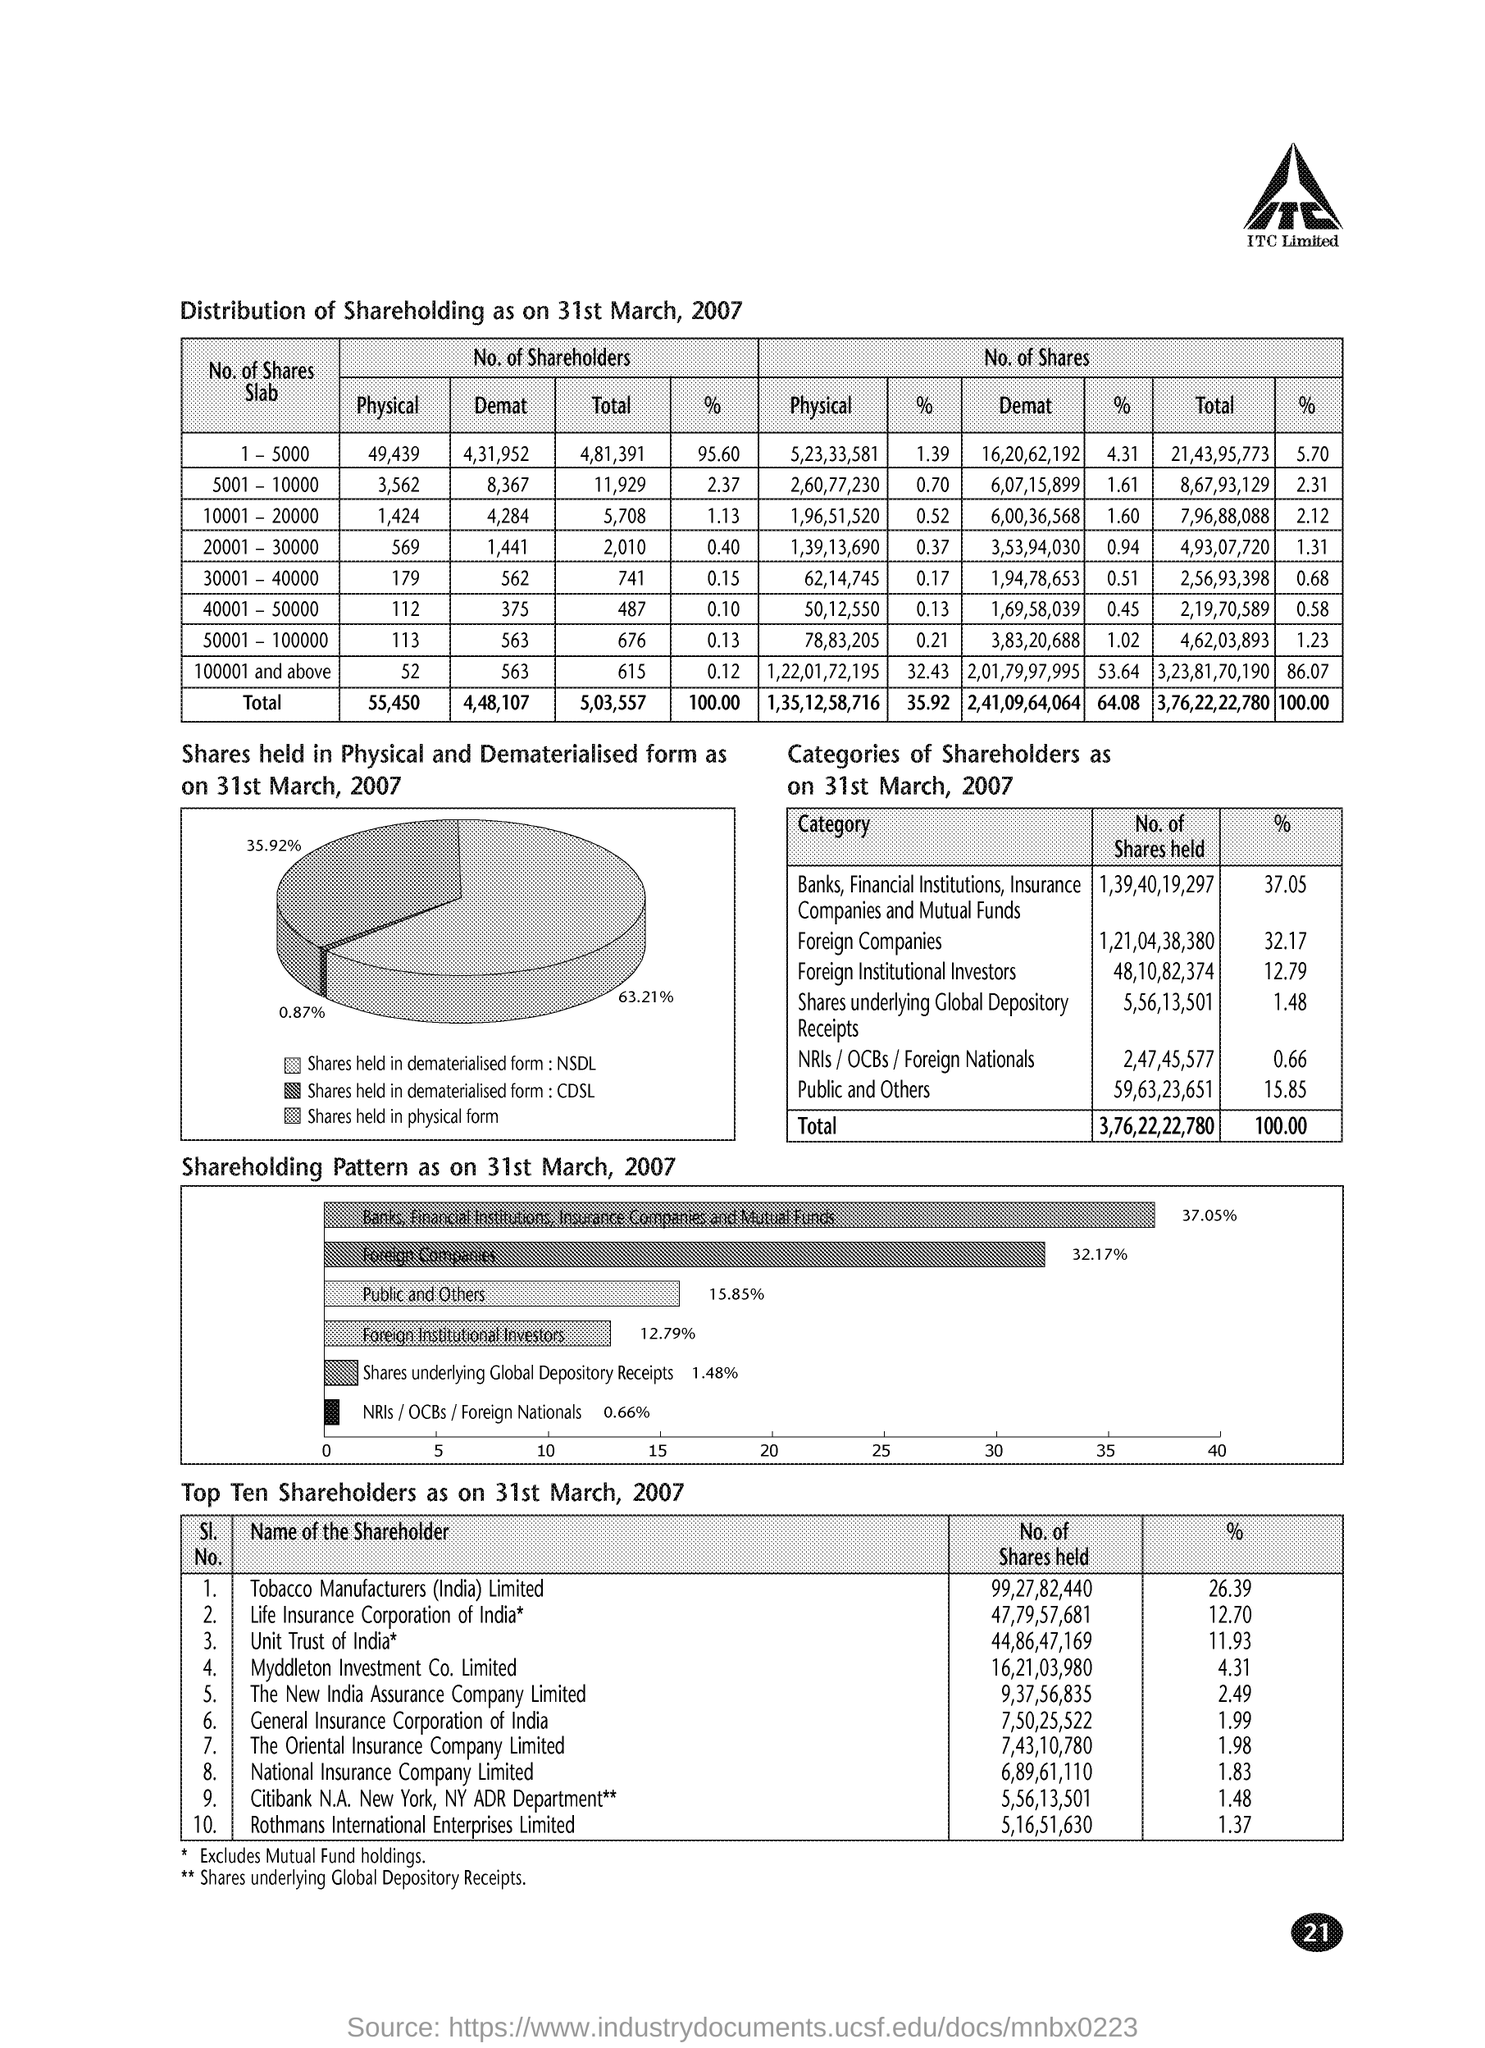What percent of share is held by Foreign Companies as on 31st March, 2007? As of 31st March, 2007, Foreign Companies held 32.17% of the total shares in the company. This is a substantial share, reflective of significant international investment and interest in the company's performance and growth prospects. 